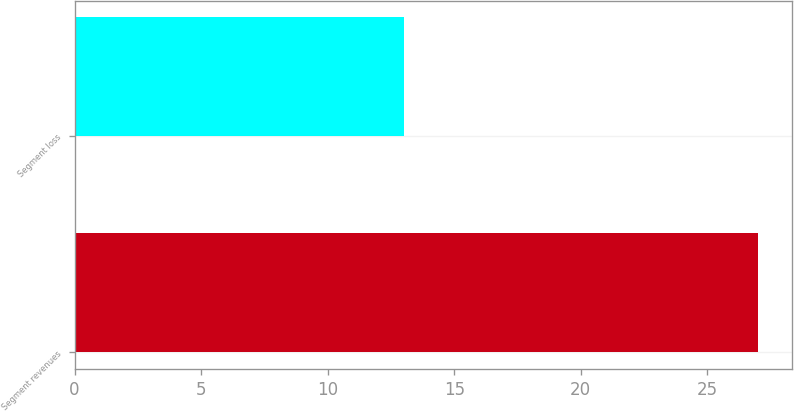Convert chart. <chart><loc_0><loc_0><loc_500><loc_500><bar_chart><fcel>Segment revenues<fcel>Segment loss<nl><fcel>27<fcel>13<nl></chart> 